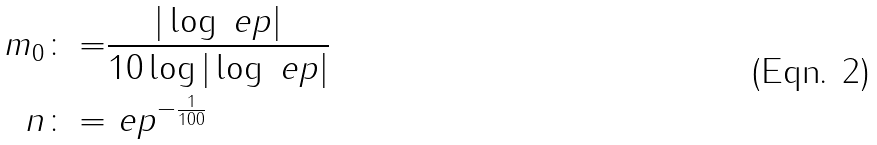<formula> <loc_0><loc_0><loc_500><loc_500>m _ { 0 } \colon = & \frac { | \log \ e p | } { 1 0 \log | \log \ e p | } \\ n \colon = & \ e p ^ { - \frac { 1 } { 1 0 0 } }</formula> 